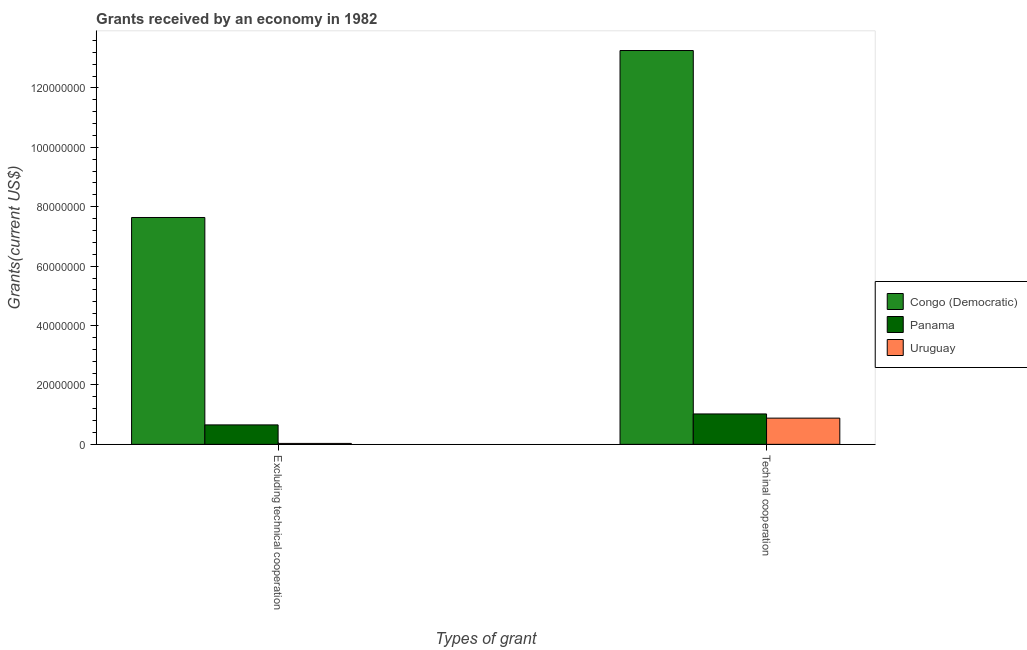How many groups of bars are there?
Offer a terse response. 2. Are the number of bars on each tick of the X-axis equal?
Provide a succinct answer. Yes. How many bars are there on the 1st tick from the left?
Offer a very short reply. 3. How many bars are there on the 2nd tick from the right?
Provide a succinct answer. 3. What is the label of the 2nd group of bars from the left?
Provide a short and direct response. Techinal cooperation. What is the amount of grants received(excluding technical cooperation) in Panama?
Your answer should be compact. 6.55e+06. Across all countries, what is the maximum amount of grants received(including technical cooperation)?
Ensure brevity in your answer.  1.33e+08. Across all countries, what is the minimum amount of grants received(including technical cooperation)?
Keep it short and to the point. 8.83e+06. In which country was the amount of grants received(including technical cooperation) maximum?
Offer a terse response. Congo (Democratic). In which country was the amount of grants received(excluding technical cooperation) minimum?
Provide a short and direct response. Uruguay. What is the total amount of grants received(excluding technical cooperation) in the graph?
Your answer should be compact. 8.32e+07. What is the difference between the amount of grants received(excluding technical cooperation) in Uruguay and that in Congo (Democratic)?
Make the answer very short. -7.60e+07. What is the difference between the amount of grants received(excluding technical cooperation) in Congo (Democratic) and the amount of grants received(including technical cooperation) in Panama?
Provide a short and direct response. 6.61e+07. What is the average amount of grants received(including technical cooperation) per country?
Give a very brief answer. 5.06e+07. What is the difference between the amount of grants received(excluding technical cooperation) and amount of grants received(including technical cooperation) in Panama?
Your answer should be very brief. -3.69e+06. What is the ratio of the amount of grants received(including technical cooperation) in Congo (Democratic) to that in Panama?
Ensure brevity in your answer.  12.95. What does the 1st bar from the left in Excluding technical cooperation represents?
Ensure brevity in your answer.  Congo (Democratic). What does the 2nd bar from the right in Excluding technical cooperation represents?
Make the answer very short. Panama. Are all the bars in the graph horizontal?
Offer a very short reply. No. How many countries are there in the graph?
Provide a succinct answer. 3. What is the difference between two consecutive major ticks on the Y-axis?
Offer a very short reply. 2.00e+07. How many legend labels are there?
Ensure brevity in your answer.  3. What is the title of the graph?
Give a very brief answer. Grants received by an economy in 1982. What is the label or title of the X-axis?
Offer a terse response. Types of grant. What is the label or title of the Y-axis?
Give a very brief answer. Grants(current US$). What is the Grants(current US$) of Congo (Democratic) in Excluding technical cooperation?
Give a very brief answer. 7.64e+07. What is the Grants(current US$) in Panama in Excluding technical cooperation?
Provide a short and direct response. 6.55e+06. What is the Grants(current US$) of Congo (Democratic) in Techinal cooperation?
Give a very brief answer. 1.33e+08. What is the Grants(current US$) in Panama in Techinal cooperation?
Your response must be concise. 1.02e+07. What is the Grants(current US$) of Uruguay in Techinal cooperation?
Your answer should be very brief. 8.83e+06. Across all Types of grant, what is the maximum Grants(current US$) in Congo (Democratic)?
Your response must be concise. 1.33e+08. Across all Types of grant, what is the maximum Grants(current US$) of Panama?
Offer a terse response. 1.02e+07. Across all Types of grant, what is the maximum Grants(current US$) of Uruguay?
Your answer should be very brief. 8.83e+06. Across all Types of grant, what is the minimum Grants(current US$) in Congo (Democratic)?
Your answer should be compact. 7.64e+07. Across all Types of grant, what is the minimum Grants(current US$) of Panama?
Provide a short and direct response. 6.55e+06. What is the total Grants(current US$) of Congo (Democratic) in the graph?
Offer a terse response. 2.09e+08. What is the total Grants(current US$) in Panama in the graph?
Provide a succinct answer. 1.68e+07. What is the total Grants(current US$) in Uruguay in the graph?
Ensure brevity in your answer.  9.15e+06. What is the difference between the Grants(current US$) in Congo (Democratic) in Excluding technical cooperation and that in Techinal cooperation?
Offer a very short reply. -5.62e+07. What is the difference between the Grants(current US$) of Panama in Excluding technical cooperation and that in Techinal cooperation?
Your response must be concise. -3.69e+06. What is the difference between the Grants(current US$) in Uruguay in Excluding technical cooperation and that in Techinal cooperation?
Keep it short and to the point. -8.51e+06. What is the difference between the Grants(current US$) of Congo (Democratic) in Excluding technical cooperation and the Grants(current US$) of Panama in Techinal cooperation?
Your answer should be very brief. 6.61e+07. What is the difference between the Grants(current US$) of Congo (Democratic) in Excluding technical cooperation and the Grants(current US$) of Uruguay in Techinal cooperation?
Your answer should be compact. 6.75e+07. What is the difference between the Grants(current US$) of Panama in Excluding technical cooperation and the Grants(current US$) of Uruguay in Techinal cooperation?
Provide a short and direct response. -2.28e+06. What is the average Grants(current US$) of Congo (Democratic) per Types of grant?
Give a very brief answer. 1.04e+08. What is the average Grants(current US$) in Panama per Types of grant?
Your response must be concise. 8.40e+06. What is the average Grants(current US$) in Uruguay per Types of grant?
Ensure brevity in your answer.  4.58e+06. What is the difference between the Grants(current US$) in Congo (Democratic) and Grants(current US$) in Panama in Excluding technical cooperation?
Your answer should be very brief. 6.98e+07. What is the difference between the Grants(current US$) in Congo (Democratic) and Grants(current US$) in Uruguay in Excluding technical cooperation?
Give a very brief answer. 7.60e+07. What is the difference between the Grants(current US$) of Panama and Grants(current US$) of Uruguay in Excluding technical cooperation?
Make the answer very short. 6.23e+06. What is the difference between the Grants(current US$) in Congo (Democratic) and Grants(current US$) in Panama in Techinal cooperation?
Give a very brief answer. 1.22e+08. What is the difference between the Grants(current US$) in Congo (Democratic) and Grants(current US$) in Uruguay in Techinal cooperation?
Offer a very short reply. 1.24e+08. What is the difference between the Grants(current US$) of Panama and Grants(current US$) of Uruguay in Techinal cooperation?
Provide a succinct answer. 1.41e+06. What is the ratio of the Grants(current US$) in Congo (Democratic) in Excluding technical cooperation to that in Techinal cooperation?
Your answer should be compact. 0.58. What is the ratio of the Grants(current US$) in Panama in Excluding technical cooperation to that in Techinal cooperation?
Give a very brief answer. 0.64. What is the ratio of the Grants(current US$) of Uruguay in Excluding technical cooperation to that in Techinal cooperation?
Offer a terse response. 0.04. What is the difference between the highest and the second highest Grants(current US$) in Congo (Democratic)?
Provide a succinct answer. 5.62e+07. What is the difference between the highest and the second highest Grants(current US$) in Panama?
Your answer should be compact. 3.69e+06. What is the difference between the highest and the second highest Grants(current US$) in Uruguay?
Your answer should be compact. 8.51e+06. What is the difference between the highest and the lowest Grants(current US$) in Congo (Democratic)?
Your answer should be very brief. 5.62e+07. What is the difference between the highest and the lowest Grants(current US$) of Panama?
Offer a terse response. 3.69e+06. What is the difference between the highest and the lowest Grants(current US$) of Uruguay?
Provide a short and direct response. 8.51e+06. 